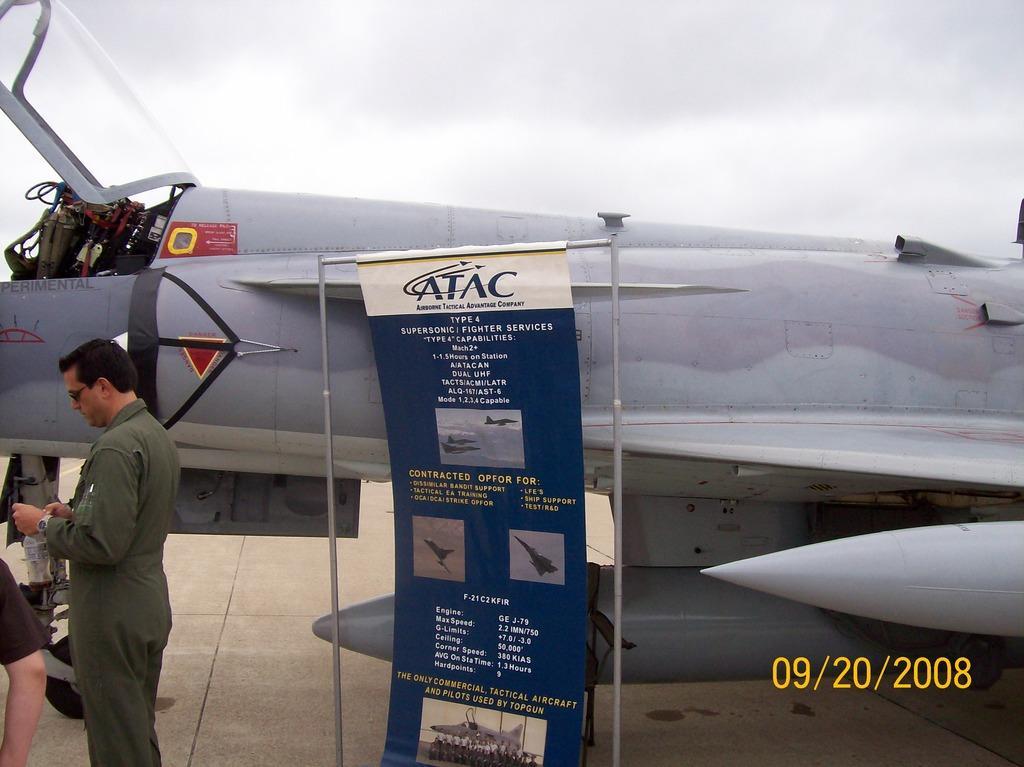Describe this image in one or two sentences. On the left, the man in the uniform is standing. Beside him, we see the leg of the woman. In the middle of the picture, we see a banner or a board in white and blue color with some text written on it. Behind that, we see an airplane in white color. At the top, we see the sky. 